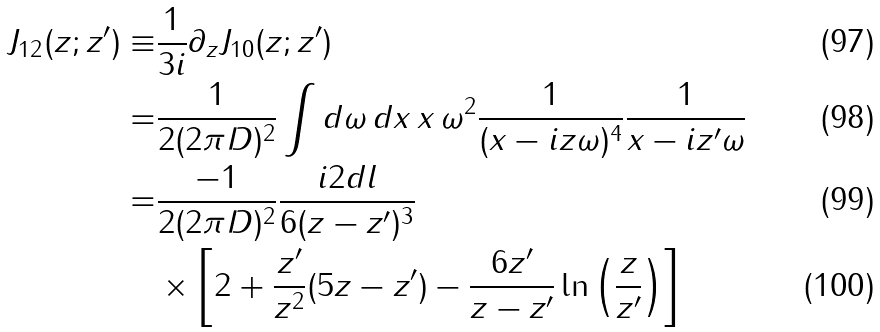<formula> <loc_0><loc_0><loc_500><loc_500>J _ { 1 2 } ( z ; z ^ { \prime } ) \equiv & \frac { 1 } { 3 i } \partial _ { z } J _ { 1 0 } ( z ; z ^ { \prime } ) \\ = & \frac { 1 } { 2 ( 2 \pi D ) ^ { 2 } } \int d \omega \, d x \, x \, \omega ^ { 2 } \frac { 1 } { ( x - i z \omega ) ^ { 4 } } \frac { 1 } { x - i z ^ { \prime } \omega } \\ = & \frac { - 1 } { 2 ( 2 \pi D ) ^ { 2 } } \frac { i 2 d l } { 6 ( z - z ^ { \prime } ) ^ { 3 } } \\ & \times \left [ 2 + \frac { z ^ { \prime } } { z ^ { 2 } } ( 5 z - z ^ { \prime } ) - \frac { 6 z ^ { \prime } } { z - z ^ { \prime } } \ln \left ( \frac { z } { z ^ { \prime } } \right ) \right ]</formula> 